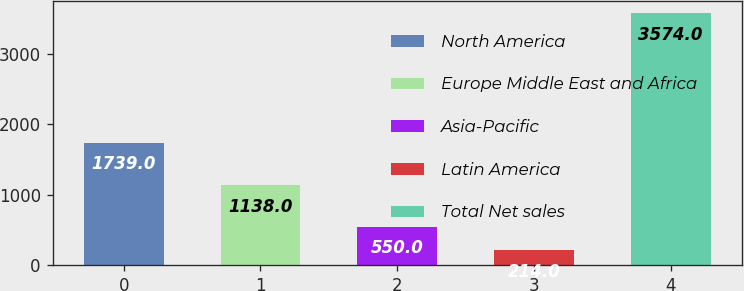Convert chart to OTSL. <chart><loc_0><loc_0><loc_500><loc_500><bar_chart><fcel>North America<fcel>Europe Middle East and Africa<fcel>Asia-Pacific<fcel>Latin America<fcel>Total Net sales<nl><fcel>1739<fcel>1138<fcel>550<fcel>214<fcel>3574<nl></chart> 